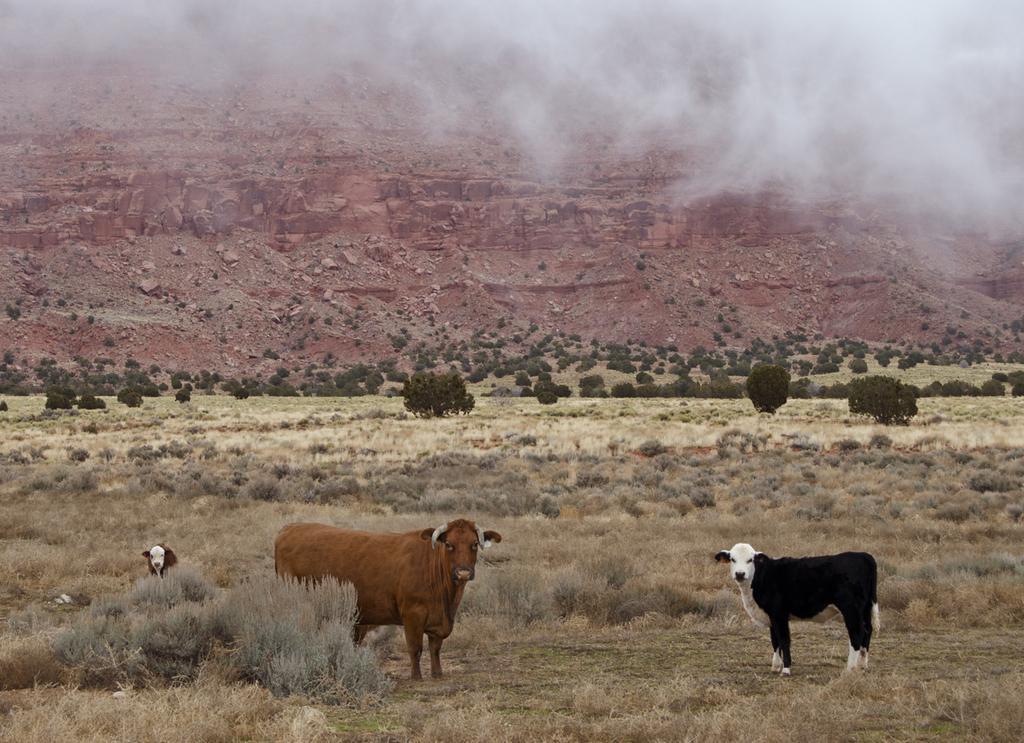Could you give a brief overview of what you see in this image? In this image in the front there are animals standing on the ground and there is dry grass on the ground and there are trees and there is smoke on the top right and in the background there are rocks. 